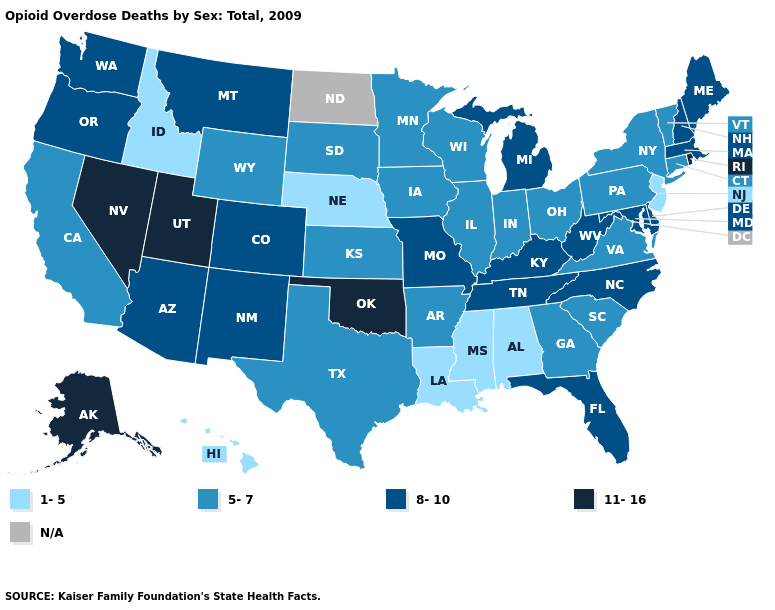What is the value of Connecticut?
Quick response, please. 5-7. Among the states that border Pennsylvania , which have the highest value?
Short answer required. Delaware, Maryland, West Virginia. What is the value of North Carolina?
Keep it brief. 8-10. Among the states that border Wisconsin , does Illinois have the lowest value?
Write a very short answer. Yes. Does Texas have the lowest value in the USA?
Concise answer only. No. Name the states that have a value in the range N/A?
Be succinct. North Dakota. Among the states that border West Virginia , which have the highest value?
Keep it brief. Kentucky, Maryland. What is the lowest value in the USA?
Keep it brief. 1-5. What is the value of Arkansas?
Answer briefly. 5-7. What is the highest value in states that border Idaho?
Write a very short answer. 11-16. Does Michigan have the highest value in the USA?
Concise answer only. No. How many symbols are there in the legend?
Write a very short answer. 5. Which states hav the highest value in the MidWest?
Keep it brief. Michigan, Missouri. 